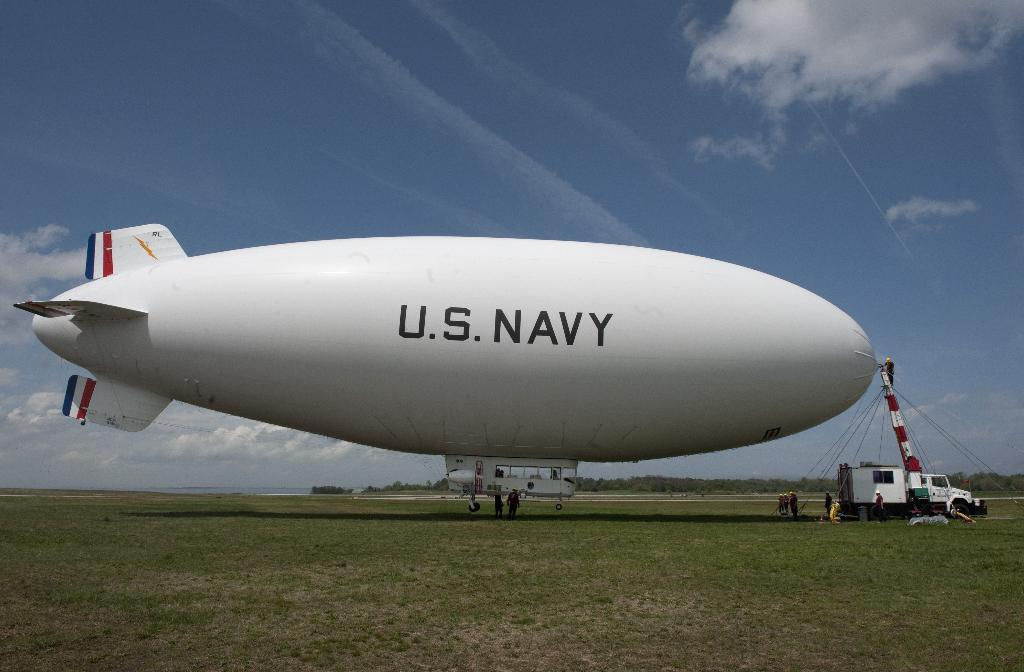<image>
Give a short and clear explanation of the subsequent image. A large white blimp has US NAVY on the side of it. 